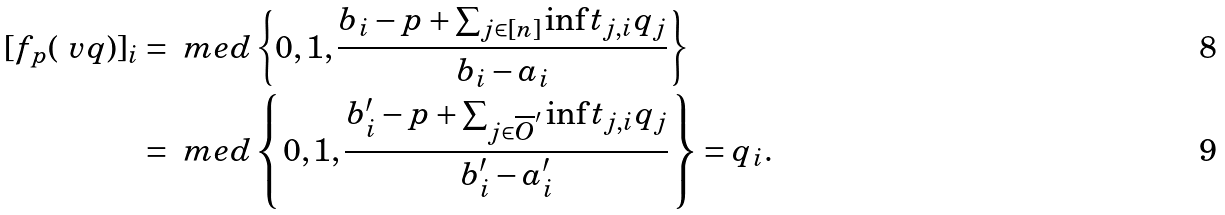Convert formula to latex. <formula><loc_0><loc_0><loc_500><loc_500>[ f _ { p } ( \ v q ) ] _ { i } & = \ m e d \left \{ 0 , 1 , \frac { b _ { i } - p + \sum _ { j \in [ n ] } { \inf t _ { j , i } q _ { j } } } { b _ { i } - a _ { i } } \right \} \\ & = \ m e d \left \{ 0 , 1 , \frac { b _ { i } ^ { \prime } - p + \sum _ { j \in \overline { O } ^ { \prime } } { \inf t _ { j , i } q _ { j } } } { b _ { i } ^ { \prime } - a _ { i } ^ { \prime } } \right \} = q _ { i } .</formula> 